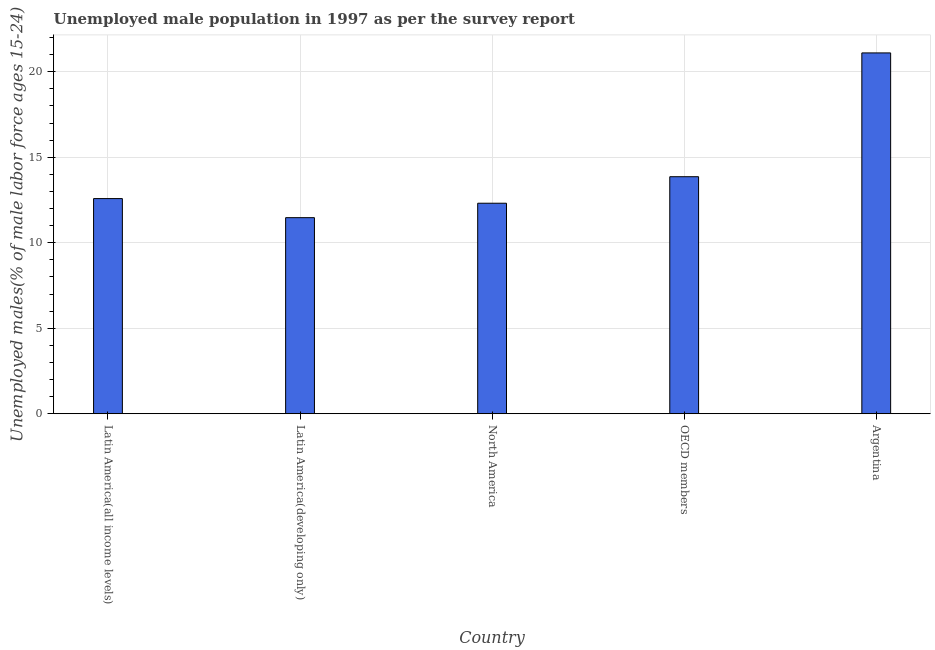Does the graph contain any zero values?
Make the answer very short. No. Does the graph contain grids?
Provide a succinct answer. Yes. What is the title of the graph?
Keep it short and to the point. Unemployed male population in 1997 as per the survey report. What is the label or title of the X-axis?
Your answer should be very brief. Country. What is the label or title of the Y-axis?
Provide a succinct answer. Unemployed males(% of male labor force ages 15-24). What is the unemployed male youth in Latin America(developing only)?
Your answer should be compact. 11.47. Across all countries, what is the maximum unemployed male youth?
Make the answer very short. 21.1. Across all countries, what is the minimum unemployed male youth?
Offer a very short reply. 11.47. In which country was the unemployed male youth minimum?
Offer a very short reply. Latin America(developing only). What is the sum of the unemployed male youth?
Provide a short and direct response. 71.32. What is the difference between the unemployed male youth in Latin America(all income levels) and OECD members?
Keep it short and to the point. -1.28. What is the average unemployed male youth per country?
Ensure brevity in your answer.  14.26. What is the median unemployed male youth?
Your response must be concise. 12.58. What is the ratio of the unemployed male youth in Latin America(developing only) to that in OECD members?
Provide a short and direct response. 0.83. Is the unemployed male youth in Latin America(all income levels) less than that in Latin America(developing only)?
Keep it short and to the point. No. What is the difference between the highest and the second highest unemployed male youth?
Your response must be concise. 7.24. What is the difference between the highest and the lowest unemployed male youth?
Your response must be concise. 9.63. In how many countries, is the unemployed male youth greater than the average unemployed male youth taken over all countries?
Offer a terse response. 1. Are all the bars in the graph horizontal?
Offer a very short reply. No. Are the values on the major ticks of Y-axis written in scientific E-notation?
Keep it short and to the point. No. What is the Unemployed males(% of male labor force ages 15-24) in Latin America(all income levels)?
Provide a short and direct response. 12.58. What is the Unemployed males(% of male labor force ages 15-24) of Latin America(developing only)?
Your answer should be very brief. 11.47. What is the Unemployed males(% of male labor force ages 15-24) in North America?
Provide a succinct answer. 12.31. What is the Unemployed males(% of male labor force ages 15-24) in OECD members?
Your response must be concise. 13.86. What is the Unemployed males(% of male labor force ages 15-24) of Argentina?
Provide a short and direct response. 21.1. What is the difference between the Unemployed males(% of male labor force ages 15-24) in Latin America(all income levels) and Latin America(developing only)?
Make the answer very short. 1.12. What is the difference between the Unemployed males(% of male labor force ages 15-24) in Latin America(all income levels) and North America?
Give a very brief answer. 0.27. What is the difference between the Unemployed males(% of male labor force ages 15-24) in Latin America(all income levels) and OECD members?
Give a very brief answer. -1.28. What is the difference between the Unemployed males(% of male labor force ages 15-24) in Latin America(all income levels) and Argentina?
Your response must be concise. -8.52. What is the difference between the Unemployed males(% of male labor force ages 15-24) in Latin America(developing only) and North America?
Keep it short and to the point. -0.84. What is the difference between the Unemployed males(% of male labor force ages 15-24) in Latin America(developing only) and OECD members?
Give a very brief answer. -2.4. What is the difference between the Unemployed males(% of male labor force ages 15-24) in Latin America(developing only) and Argentina?
Offer a very short reply. -9.63. What is the difference between the Unemployed males(% of male labor force ages 15-24) in North America and OECD members?
Ensure brevity in your answer.  -1.55. What is the difference between the Unemployed males(% of male labor force ages 15-24) in North America and Argentina?
Ensure brevity in your answer.  -8.79. What is the difference between the Unemployed males(% of male labor force ages 15-24) in OECD members and Argentina?
Provide a short and direct response. -7.24. What is the ratio of the Unemployed males(% of male labor force ages 15-24) in Latin America(all income levels) to that in Latin America(developing only)?
Offer a very short reply. 1.1. What is the ratio of the Unemployed males(% of male labor force ages 15-24) in Latin America(all income levels) to that in OECD members?
Your response must be concise. 0.91. What is the ratio of the Unemployed males(% of male labor force ages 15-24) in Latin America(all income levels) to that in Argentina?
Make the answer very short. 0.6. What is the ratio of the Unemployed males(% of male labor force ages 15-24) in Latin America(developing only) to that in North America?
Your response must be concise. 0.93. What is the ratio of the Unemployed males(% of male labor force ages 15-24) in Latin America(developing only) to that in OECD members?
Ensure brevity in your answer.  0.83. What is the ratio of the Unemployed males(% of male labor force ages 15-24) in Latin America(developing only) to that in Argentina?
Ensure brevity in your answer.  0.54. What is the ratio of the Unemployed males(% of male labor force ages 15-24) in North America to that in OECD members?
Keep it short and to the point. 0.89. What is the ratio of the Unemployed males(% of male labor force ages 15-24) in North America to that in Argentina?
Give a very brief answer. 0.58. What is the ratio of the Unemployed males(% of male labor force ages 15-24) in OECD members to that in Argentina?
Offer a terse response. 0.66. 